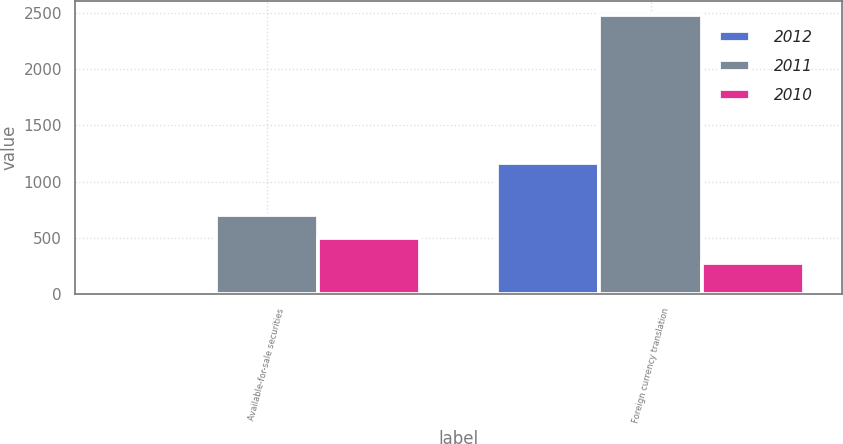<chart> <loc_0><loc_0><loc_500><loc_500><stacked_bar_chart><ecel><fcel>Available-for-sale securities<fcel>Foreign currency translation<nl><fcel>2012<fcel>13<fcel>1169<nl><fcel>2011<fcel>700<fcel>2483<nl><fcel>2010<fcel>495<fcel>275<nl></chart> 